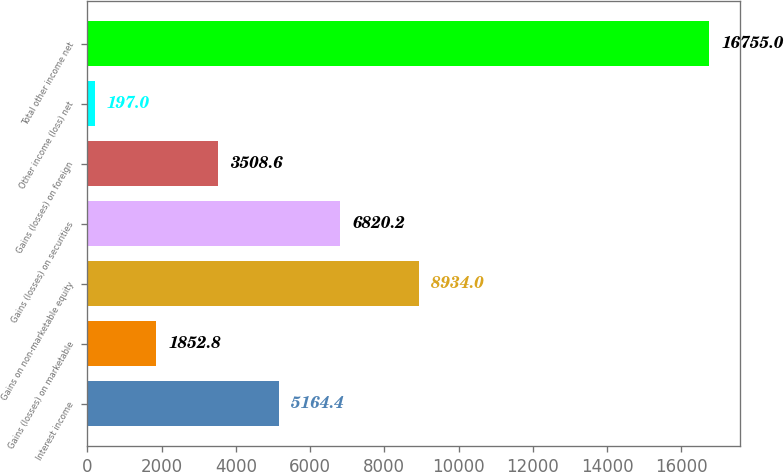Convert chart. <chart><loc_0><loc_0><loc_500><loc_500><bar_chart><fcel>Interest income<fcel>Gains (losses) on marketable<fcel>Gains on non-marketable equity<fcel>Gains (losses) on securities<fcel>Gains (losses) on foreign<fcel>Other income (loss) net<fcel>Total other income net<nl><fcel>5164.4<fcel>1852.8<fcel>8934<fcel>6820.2<fcel>3508.6<fcel>197<fcel>16755<nl></chart> 